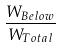Convert formula to latex. <formula><loc_0><loc_0><loc_500><loc_500>\frac { W _ { B e l o w } } { W _ { T o t a l } }</formula> 